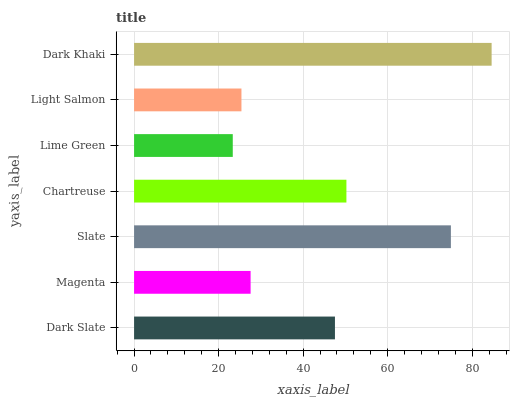Is Lime Green the minimum?
Answer yes or no. Yes. Is Dark Khaki the maximum?
Answer yes or no. Yes. Is Magenta the minimum?
Answer yes or no. No. Is Magenta the maximum?
Answer yes or no. No. Is Dark Slate greater than Magenta?
Answer yes or no. Yes. Is Magenta less than Dark Slate?
Answer yes or no. Yes. Is Magenta greater than Dark Slate?
Answer yes or no. No. Is Dark Slate less than Magenta?
Answer yes or no. No. Is Dark Slate the high median?
Answer yes or no. Yes. Is Dark Slate the low median?
Answer yes or no. Yes. Is Magenta the high median?
Answer yes or no. No. Is Dark Khaki the low median?
Answer yes or no. No. 